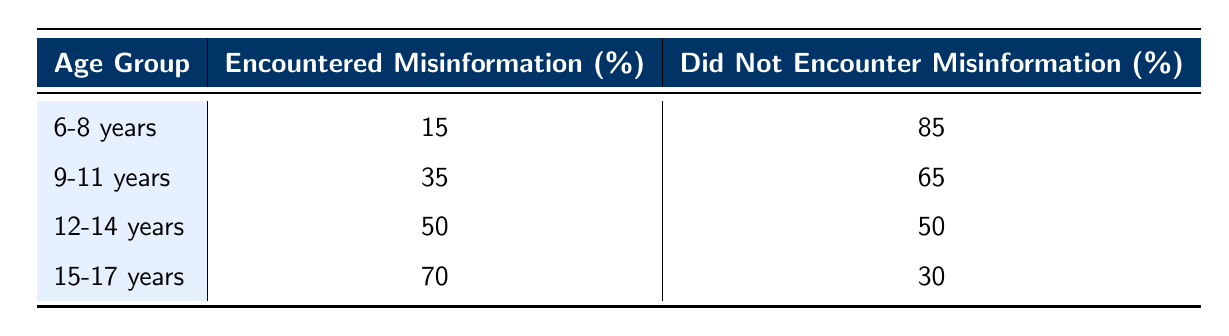What percentage of students aged 6-8 years have encountered misinformation? According to the table, the percentage of students in the 6-8 years age group who have encountered misinformation is given as 15%.
Answer: 15% What is the percentage of students aged 15-17 years who did not encounter misinformation? The table shows that the percentage of students aged 15-17 years who did not encounter misinformation is 30%.
Answer: 30% Which age group has the highest percentage of encountering misinformation? By examining the table, it is clear that the age group 15-17 years has the highest percentage of encountering misinformation at 70%.
Answer: 15-17 years What is the difference in the percentage of students who encountered misinformation between the 12-14 years and 9-11 years age groups? For the 12-14 years age group, 50% encountered misinformation and for the 9-11 years age group, it is 35%. The difference is calculated as 50 - 35 = 15%.
Answer: 15% Is it true that more than half of the students aged 12-14 years encountered misinformation? The data shows that 50% of the students in the 12-14 years age group encountered misinformation, which is not more than half. Thus, the statement is false.
Answer: No What is the total percentage of students who encountered misinformation across all age groups? To find the total percentage, we add the percentages from each age group: 15 + 35 + 50 + 70 = 170%. This number represents the sum but not a valid statistical percentage as it exceeds 100%.
Answer: 170% What can we infer about the trend of misinformation encounters as age increases? Looking at the table, we see that as the age increases, the percentage of students encountering misinformation also increases from 15% for 6-8 years to 70% for 15-17 years, indicating a trend of more encounters with misinformation among older students.
Answer: The trend shows an increase What is the average percentage of students encountering misinformation across all age groups? To calculate the average, sum the encountered misinformation percentages (15 + 35 + 50 + 70 = 170) and divide by the number of age groups (4). Therefore, the average is 170 / 4 = 42.5%.
Answer: 42.5% 